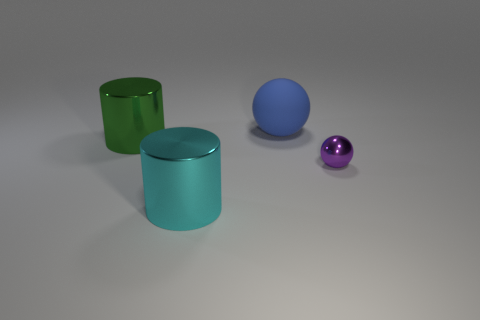There is a large thing that is the same shape as the tiny metal object; what color is it?
Provide a short and direct response. Blue. Is the color of the small metal ball the same as the cylinder that is behind the big cyan cylinder?
Your response must be concise. No. There is a metallic thing that is both on the left side of the big blue rubber sphere and in front of the big green cylinder; what shape is it?
Ensure brevity in your answer.  Cylinder. There is a thing behind the cylinder behind the ball that is in front of the big green thing; what is it made of?
Your answer should be very brief. Rubber. Is the number of tiny spheres on the right side of the cyan metal thing greater than the number of large cyan cylinders that are behind the shiny sphere?
Provide a short and direct response. Yes. How many large cylinders have the same material as the tiny sphere?
Your response must be concise. 2. Do the metallic thing that is to the left of the large cyan object and the big metal object in front of the small purple object have the same shape?
Your response must be concise. Yes. There is a ball that is to the left of the tiny metal ball; what color is it?
Make the answer very short. Blue. Is there a big yellow rubber object that has the same shape as the small shiny object?
Give a very brief answer. No. What material is the big ball?
Provide a short and direct response. Rubber. 